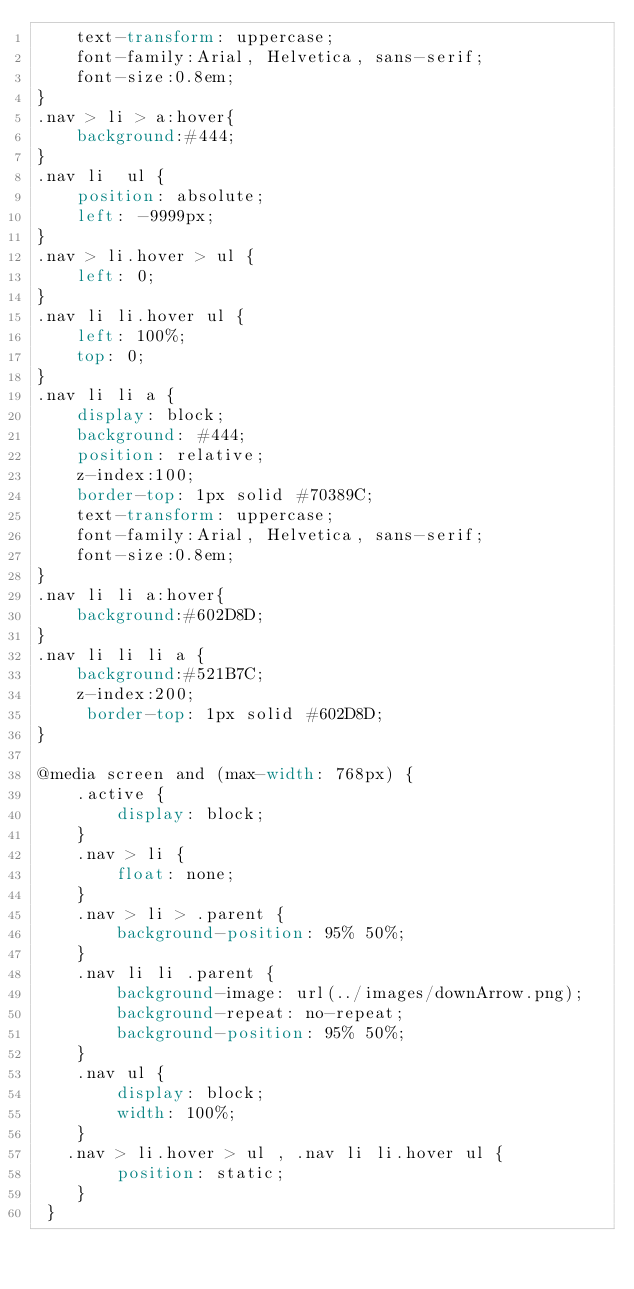<code> <loc_0><loc_0><loc_500><loc_500><_CSS_>    text-transform: uppercase;
	font-family:Arial, Helvetica, sans-serif;
	font-size:0.8em;
}
.nav > li > a:hover{
	background:#444;
}
.nav li  ul {
    position: absolute;
    left: -9999px;
}
.nav > li.hover > ul {
    left: 0;
}
.nav li li.hover ul {
    left: 100%;
    top: 0;
}
.nav li li a {
    display: block;
    background: #444;
    position: relative;
    z-index:100;
    border-top: 1px solid #70389C;
    text-transform: uppercase;
	font-family:Arial, Helvetica, sans-serif;
	font-size:0.8em;
}
.nav li li a:hover{
	background:#602D8D;
}
.nav li li li a {
  	background:#521B7C;
    z-index:200;
     border-top: 1px solid #602D8D;
}

@media screen and (max-width: 768px) {
    .active {
        display: block;
    }
    .nav > li {
        float: none;
    }
    .nav > li > .parent {
        background-position: 95% 50%;
    }
    .nav li li .parent {
        background-image: url(../images/downArrow.png);
       	background-repeat: no-repeat;
        background-position: 95% 50%;
    }
    .nav ul {
        display: block;
        width: 100%;
    }
   .nav > li.hover > ul , .nav li li.hover ul {
        position: static;
    }
 }</code> 